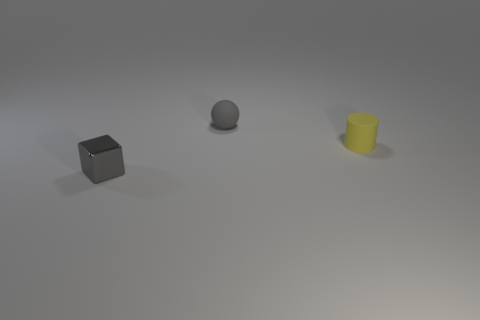Add 1 balls. How many objects exist? 4 Subtract 0 yellow cubes. How many objects are left? 3 Subtract all cylinders. How many objects are left? 2 Subtract all red cylinders. Subtract all brown spheres. How many cylinders are left? 1 Subtract all matte objects. Subtract all yellow rubber things. How many objects are left? 0 Add 3 small gray things. How many small gray things are left? 5 Add 1 rubber things. How many rubber things exist? 3 